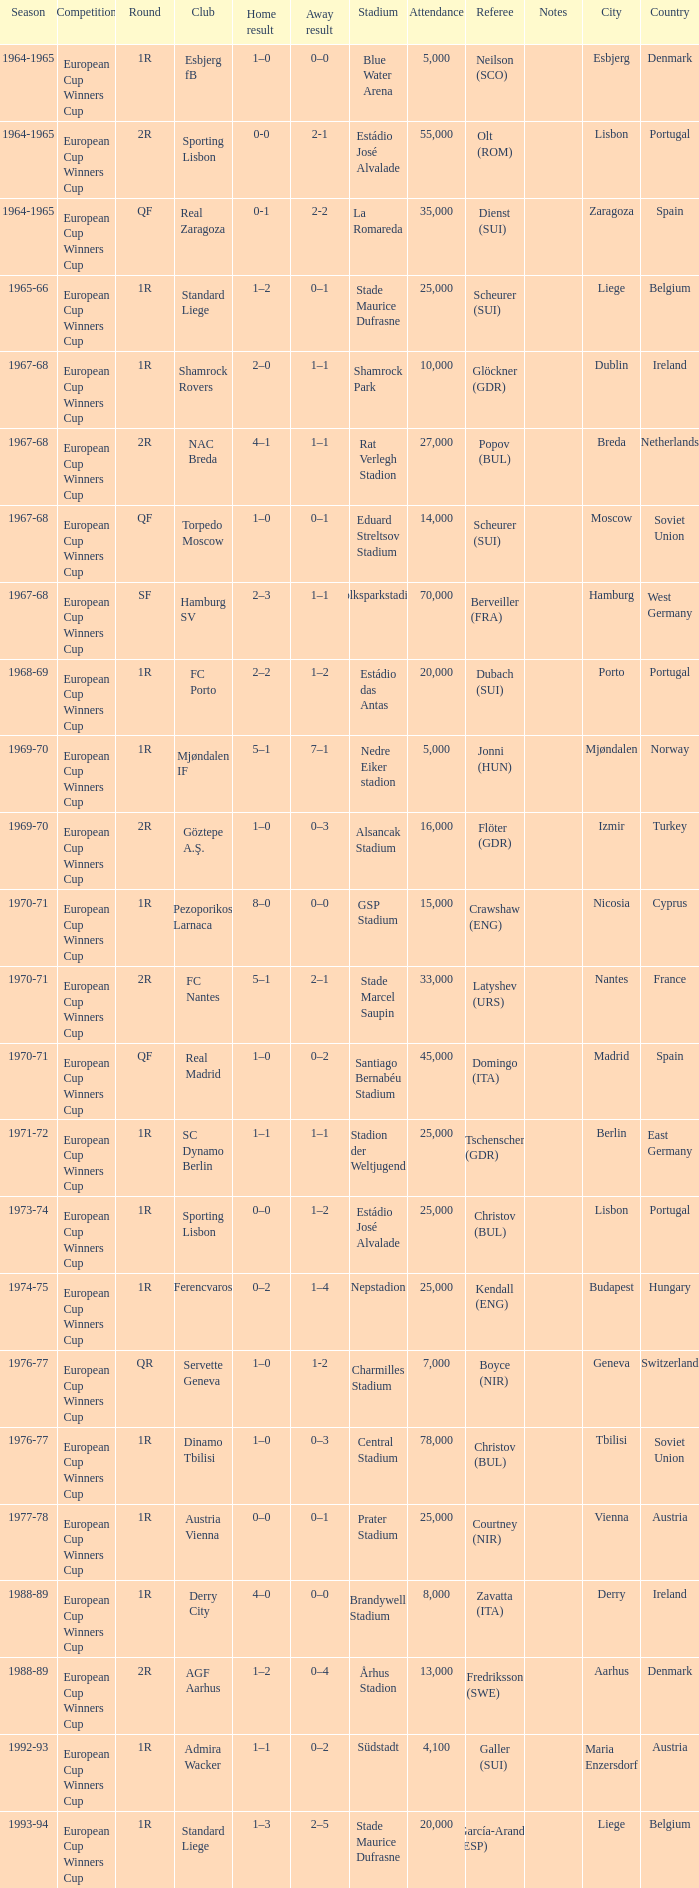Away result of 1-2 has what season? 1976-77. 